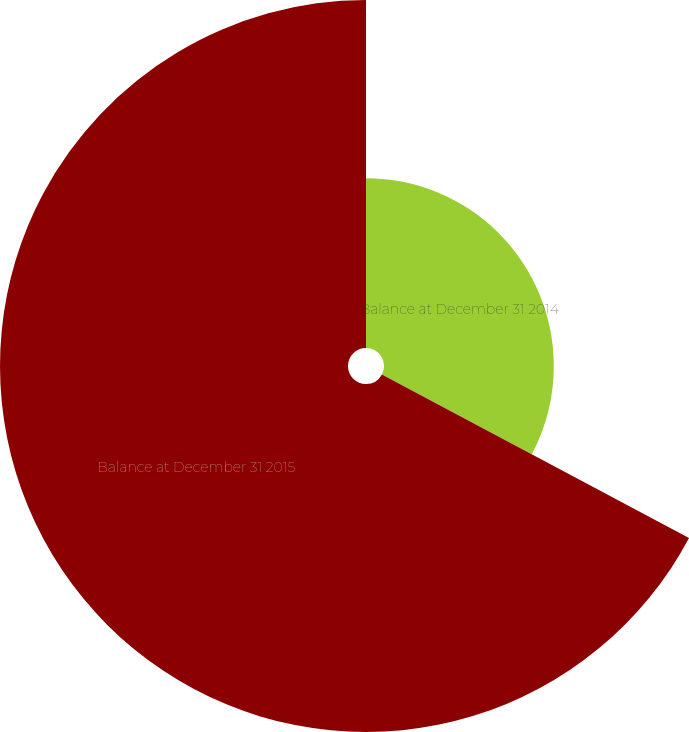Convert chart. <chart><loc_0><loc_0><loc_500><loc_500><pie_chart><fcel>Balance at December 31 2014<fcel>Balance at December 31 2015<nl><fcel>32.79%<fcel>67.21%<nl></chart> 